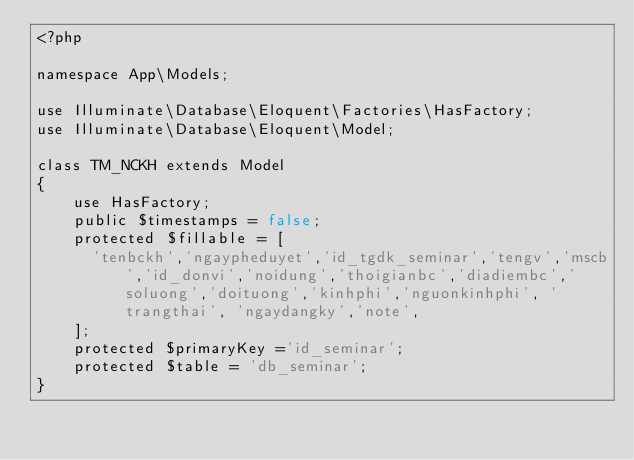<code> <loc_0><loc_0><loc_500><loc_500><_PHP_><?php

namespace App\Models;

use Illuminate\Database\Eloquent\Factories\HasFactory;
use Illuminate\Database\Eloquent\Model;

class TM_NCKH extends Model
{
    use HasFactory;
    public $timestamps = false;
    protected $fillable = [
    	'tenbckh','ngaypheduyet','id_tgdk_seminar','tengv','mscb','id_donvi','noidung','thoigianbc','diadiembc','soluong','doituong','kinhphi','nguonkinhphi', 'trangthai', 'ngaydangky','note',
    ];
    protected $primaryKey ='id_seminar';
    protected $table = 'db_seminar';
}
</code> 